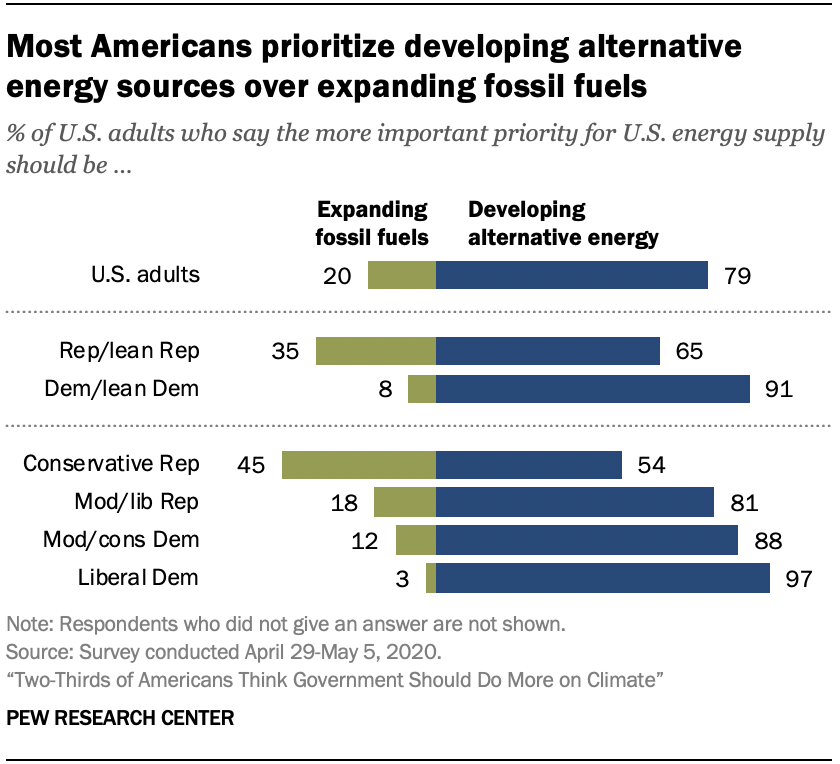List a handful of essential elements in this visual. In the comparison of U.S adults, the ratio between two factors is 0.888194444... The chart shows that 79% of U.S. adults believe that developing alternative energy sources should be the top priority for U.S. energy supply. 